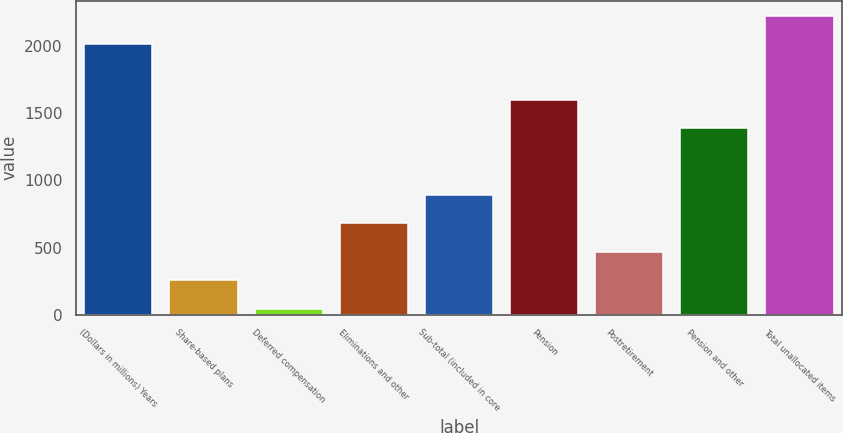<chart> <loc_0><loc_0><loc_500><loc_500><bar_chart><fcel>(Dollars in millions) Years<fcel>Share-based plans<fcel>Deferred compensation<fcel>Eliminations and other<fcel>Sub-total (included in core<fcel>Pension<fcel>Postretirement<fcel>Pension and other<fcel>Total unallocated items<nl><fcel>2014<fcel>255.9<fcel>44<fcel>679.7<fcel>891.6<fcel>1598.9<fcel>467.8<fcel>1387<fcel>2225.9<nl></chart> 